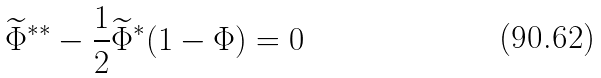Convert formula to latex. <formula><loc_0><loc_0><loc_500><loc_500>\widetilde { \Phi } ^ { \ast \ast } - \frac { 1 } { 2 } \widetilde { \Phi } ^ { \ast } ( 1 - \Phi ) = 0</formula> 